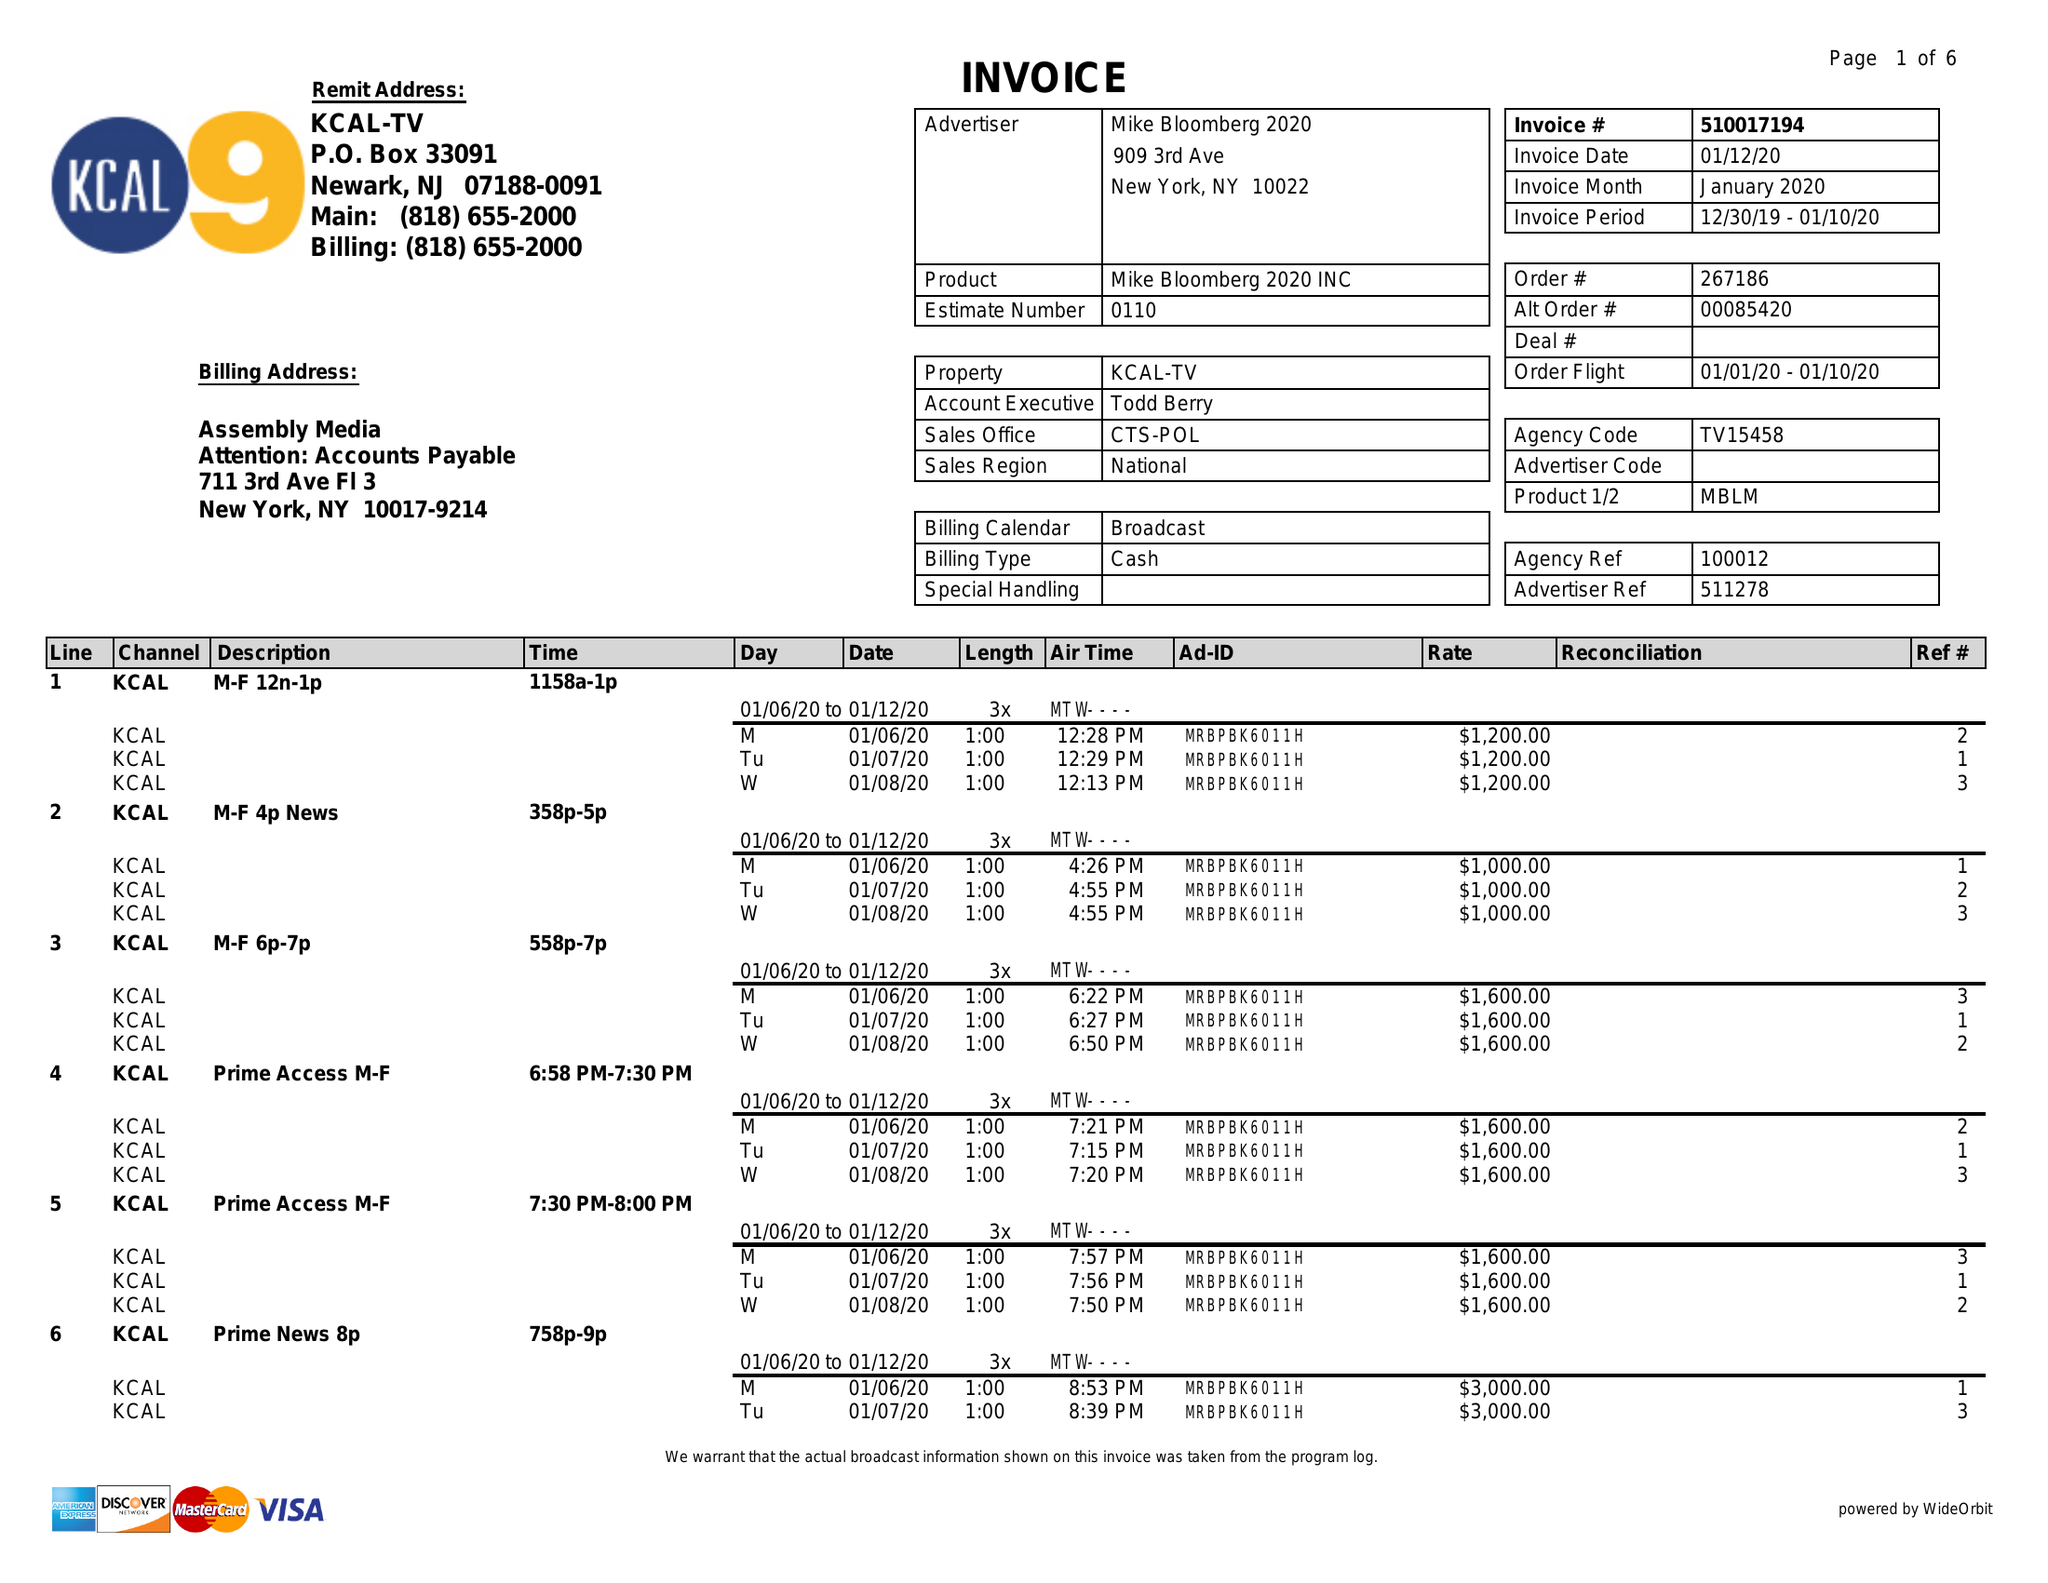What is the value for the contract_num?
Answer the question using a single word or phrase. 510017194 